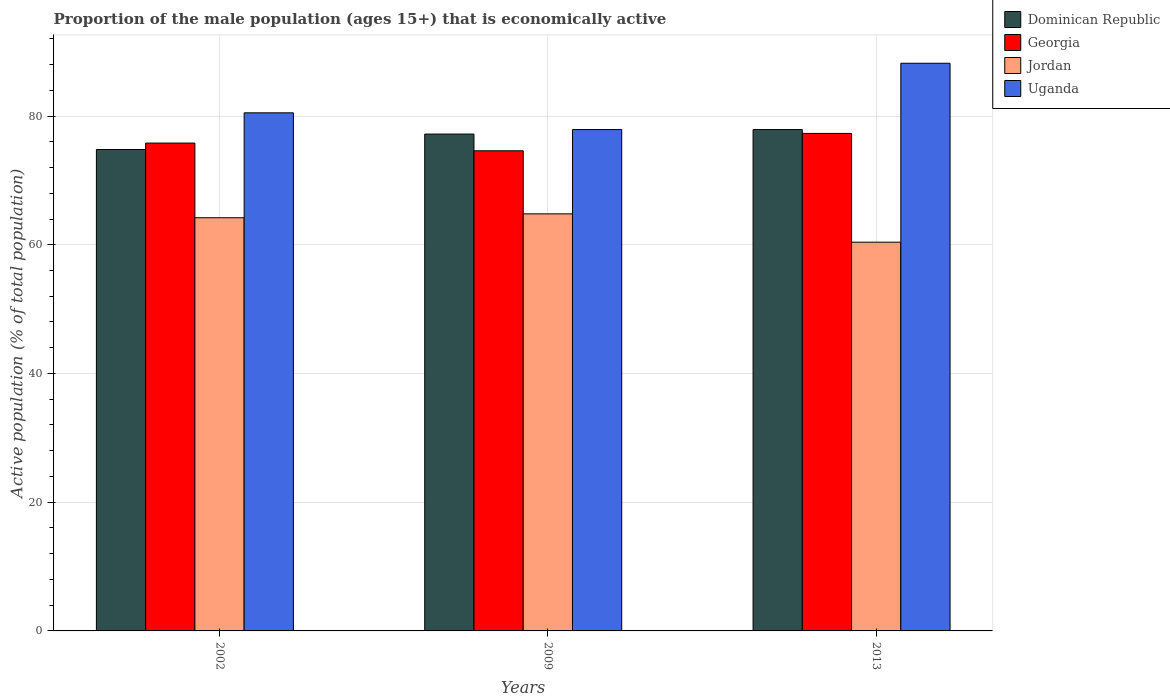How many different coloured bars are there?
Give a very brief answer. 4. Are the number of bars per tick equal to the number of legend labels?
Keep it short and to the point. Yes. Are the number of bars on each tick of the X-axis equal?
Offer a terse response. Yes. How many bars are there on the 3rd tick from the right?
Offer a very short reply. 4. What is the label of the 1st group of bars from the left?
Your answer should be compact. 2002. In how many cases, is the number of bars for a given year not equal to the number of legend labels?
Offer a very short reply. 0. What is the proportion of the male population that is economically active in Uganda in 2009?
Provide a succinct answer. 77.9. Across all years, what is the maximum proportion of the male population that is economically active in Dominican Republic?
Offer a terse response. 77.9. Across all years, what is the minimum proportion of the male population that is economically active in Georgia?
Your answer should be very brief. 74.6. What is the total proportion of the male population that is economically active in Uganda in the graph?
Provide a succinct answer. 246.6. What is the difference between the proportion of the male population that is economically active in Georgia in 2002 and that in 2009?
Your answer should be very brief. 1.2. What is the difference between the proportion of the male population that is economically active in Uganda in 2002 and the proportion of the male population that is economically active in Jordan in 2013?
Your response must be concise. 20.1. What is the average proportion of the male population that is economically active in Jordan per year?
Offer a very short reply. 63.13. In the year 2002, what is the difference between the proportion of the male population that is economically active in Jordan and proportion of the male population that is economically active in Dominican Republic?
Keep it short and to the point. -10.6. What is the ratio of the proportion of the male population that is economically active in Jordan in 2009 to that in 2013?
Offer a very short reply. 1.07. Is the proportion of the male population that is economically active in Jordan in 2002 less than that in 2009?
Give a very brief answer. Yes. Is the difference between the proportion of the male population that is economically active in Jordan in 2002 and 2013 greater than the difference between the proportion of the male population that is economically active in Dominican Republic in 2002 and 2013?
Keep it short and to the point. Yes. What is the difference between the highest and the second highest proportion of the male population that is economically active in Jordan?
Provide a succinct answer. 0.6. What is the difference between the highest and the lowest proportion of the male population that is economically active in Georgia?
Ensure brevity in your answer.  2.7. In how many years, is the proportion of the male population that is economically active in Uganda greater than the average proportion of the male population that is economically active in Uganda taken over all years?
Your response must be concise. 1. What does the 3rd bar from the left in 2009 represents?
Give a very brief answer. Jordan. What does the 2nd bar from the right in 2009 represents?
Give a very brief answer. Jordan. Where does the legend appear in the graph?
Provide a short and direct response. Top right. How many legend labels are there?
Your answer should be compact. 4. What is the title of the graph?
Give a very brief answer. Proportion of the male population (ages 15+) that is economically active. Does "Guam" appear as one of the legend labels in the graph?
Offer a very short reply. No. What is the label or title of the X-axis?
Ensure brevity in your answer.  Years. What is the label or title of the Y-axis?
Your response must be concise. Active population (% of total population). What is the Active population (% of total population) in Dominican Republic in 2002?
Provide a succinct answer. 74.8. What is the Active population (% of total population) of Georgia in 2002?
Provide a succinct answer. 75.8. What is the Active population (% of total population) of Jordan in 2002?
Provide a succinct answer. 64.2. What is the Active population (% of total population) of Uganda in 2002?
Your response must be concise. 80.5. What is the Active population (% of total population) in Dominican Republic in 2009?
Offer a very short reply. 77.2. What is the Active population (% of total population) of Georgia in 2009?
Make the answer very short. 74.6. What is the Active population (% of total population) in Jordan in 2009?
Your answer should be compact. 64.8. What is the Active population (% of total population) of Uganda in 2009?
Your answer should be very brief. 77.9. What is the Active population (% of total population) in Dominican Republic in 2013?
Your answer should be very brief. 77.9. What is the Active population (% of total population) in Georgia in 2013?
Offer a terse response. 77.3. What is the Active population (% of total population) of Jordan in 2013?
Your answer should be compact. 60.4. What is the Active population (% of total population) of Uganda in 2013?
Provide a succinct answer. 88.2. Across all years, what is the maximum Active population (% of total population) of Dominican Republic?
Make the answer very short. 77.9. Across all years, what is the maximum Active population (% of total population) of Georgia?
Make the answer very short. 77.3. Across all years, what is the maximum Active population (% of total population) in Jordan?
Make the answer very short. 64.8. Across all years, what is the maximum Active population (% of total population) of Uganda?
Provide a short and direct response. 88.2. Across all years, what is the minimum Active population (% of total population) of Dominican Republic?
Your answer should be very brief. 74.8. Across all years, what is the minimum Active population (% of total population) in Georgia?
Provide a short and direct response. 74.6. Across all years, what is the minimum Active population (% of total population) in Jordan?
Ensure brevity in your answer.  60.4. Across all years, what is the minimum Active population (% of total population) in Uganda?
Give a very brief answer. 77.9. What is the total Active population (% of total population) in Dominican Republic in the graph?
Offer a terse response. 229.9. What is the total Active population (% of total population) in Georgia in the graph?
Make the answer very short. 227.7. What is the total Active population (% of total population) in Jordan in the graph?
Ensure brevity in your answer.  189.4. What is the total Active population (% of total population) of Uganda in the graph?
Your response must be concise. 246.6. What is the difference between the Active population (% of total population) in Jordan in 2002 and that in 2009?
Make the answer very short. -0.6. What is the difference between the Active population (% of total population) in Uganda in 2002 and that in 2009?
Ensure brevity in your answer.  2.6. What is the difference between the Active population (% of total population) of Dominican Republic in 2002 and that in 2013?
Your response must be concise. -3.1. What is the difference between the Active population (% of total population) in Georgia in 2002 and that in 2013?
Your answer should be very brief. -1.5. What is the difference between the Active population (% of total population) in Jordan in 2002 and that in 2013?
Provide a short and direct response. 3.8. What is the difference between the Active population (% of total population) in Jordan in 2009 and that in 2013?
Keep it short and to the point. 4.4. What is the difference between the Active population (% of total population) of Uganda in 2009 and that in 2013?
Your answer should be compact. -10.3. What is the difference between the Active population (% of total population) in Dominican Republic in 2002 and the Active population (% of total population) in Uganda in 2009?
Your answer should be very brief. -3.1. What is the difference between the Active population (% of total population) in Georgia in 2002 and the Active population (% of total population) in Jordan in 2009?
Your answer should be very brief. 11. What is the difference between the Active population (% of total population) in Georgia in 2002 and the Active population (% of total population) in Uganda in 2009?
Provide a succinct answer. -2.1. What is the difference between the Active population (% of total population) in Jordan in 2002 and the Active population (% of total population) in Uganda in 2009?
Offer a very short reply. -13.7. What is the difference between the Active population (% of total population) in Georgia in 2002 and the Active population (% of total population) in Jordan in 2013?
Your response must be concise. 15.4. What is the difference between the Active population (% of total population) of Dominican Republic in 2009 and the Active population (% of total population) of Georgia in 2013?
Keep it short and to the point. -0.1. What is the difference between the Active population (% of total population) of Georgia in 2009 and the Active population (% of total population) of Jordan in 2013?
Keep it short and to the point. 14.2. What is the difference between the Active population (% of total population) in Georgia in 2009 and the Active population (% of total population) in Uganda in 2013?
Make the answer very short. -13.6. What is the difference between the Active population (% of total population) of Jordan in 2009 and the Active population (% of total population) of Uganda in 2013?
Your answer should be very brief. -23.4. What is the average Active population (% of total population) in Dominican Republic per year?
Keep it short and to the point. 76.63. What is the average Active population (% of total population) of Georgia per year?
Your answer should be very brief. 75.9. What is the average Active population (% of total population) in Jordan per year?
Provide a succinct answer. 63.13. What is the average Active population (% of total population) of Uganda per year?
Make the answer very short. 82.2. In the year 2002, what is the difference between the Active population (% of total population) in Dominican Republic and Active population (% of total population) in Jordan?
Make the answer very short. 10.6. In the year 2002, what is the difference between the Active population (% of total population) in Dominican Republic and Active population (% of total population) in Uganda?
Ensure brevity in your answer.  -5.7. In the year 2002, what is the difference between the Active population (% of total population) in Georgia and Active population (% of total population) in Jordan?
Make the answer very short. 11.6. In the year 2002, what is the difference between the Active population (% of total population) in Jordan and Active population (% of total population) in Uganda?
Provide a succinct answer. -16.3. In the year 2009, what is the difference between the Active population (% of total population) in Dominican Republic and Active population (% of total population) in Uganda?
Your answer should be very brief. -0.7. In the year 2013, what is the difference between the Active population (% of total population) in Georgia and Active population (% of total population) in Uganda?
Your response must be concise. -10.9. In the year 2013, what is the difference between the Active population (% of total population) of Jordan and Active population (% of total population) of Uganda?
Give a very brief answer. -27.8. What is the ratio of the Active population (% of total population) of Dominican Republic in 2002 to that in 2009?
Offer a very short reply. 0.97. What is the ratio of the Active population (% of total population) of Georgia in 2002 to that in 2009?
Your answer should be very brief. 1.02. What is the ratio of the Active population (% of total population) in Uganda in 2002 to that in 2009?
Your answer should be compact. 1.03. What is the ratio of the Active population (% of total population) of Dominican Republic in 2002 to that in 2013?
Provide a short and direct response. 0.96. What is the ratio of the Active population (% of total population) in Georgia in 2002 to that in 2013?
Provide a short and direct response. 0.98. What is the ratio of the Active population (% of total population) in Jordan in 2002 to that in 2013?
Ensure brevity in your answer.  1.06. What is the ratio of the Active population (% of total population) in Uganda in 2002 to that in 2013?
Give a very brief answer. 0.91. What is the ratio of the Active population (% of total population) in Georgia in 2009 to that in 2013?
Your answer should be very brief. 0.97. What is the ratio of the Active population (% of total population) in Jordan in 2009 to that in 2013?
Your response must be concise. 1.07. What is the ratio of the Active population (% of total population) of Uganda in 2009 to that in 2013?
Provide a short and direct response. 0.88. What is the difference between the highest and the second highest Active population (% of total population) in Uganda?
Make the answer very short. 7.7. What is the difference between the highest and the lowest Active population (% of total population) in Dominican Republic?
Make the answer very short. 3.1. What is the difference between the highest and the lowest Active population (% of total population) in Uganda?
Give a very brief answer. 10.3. 